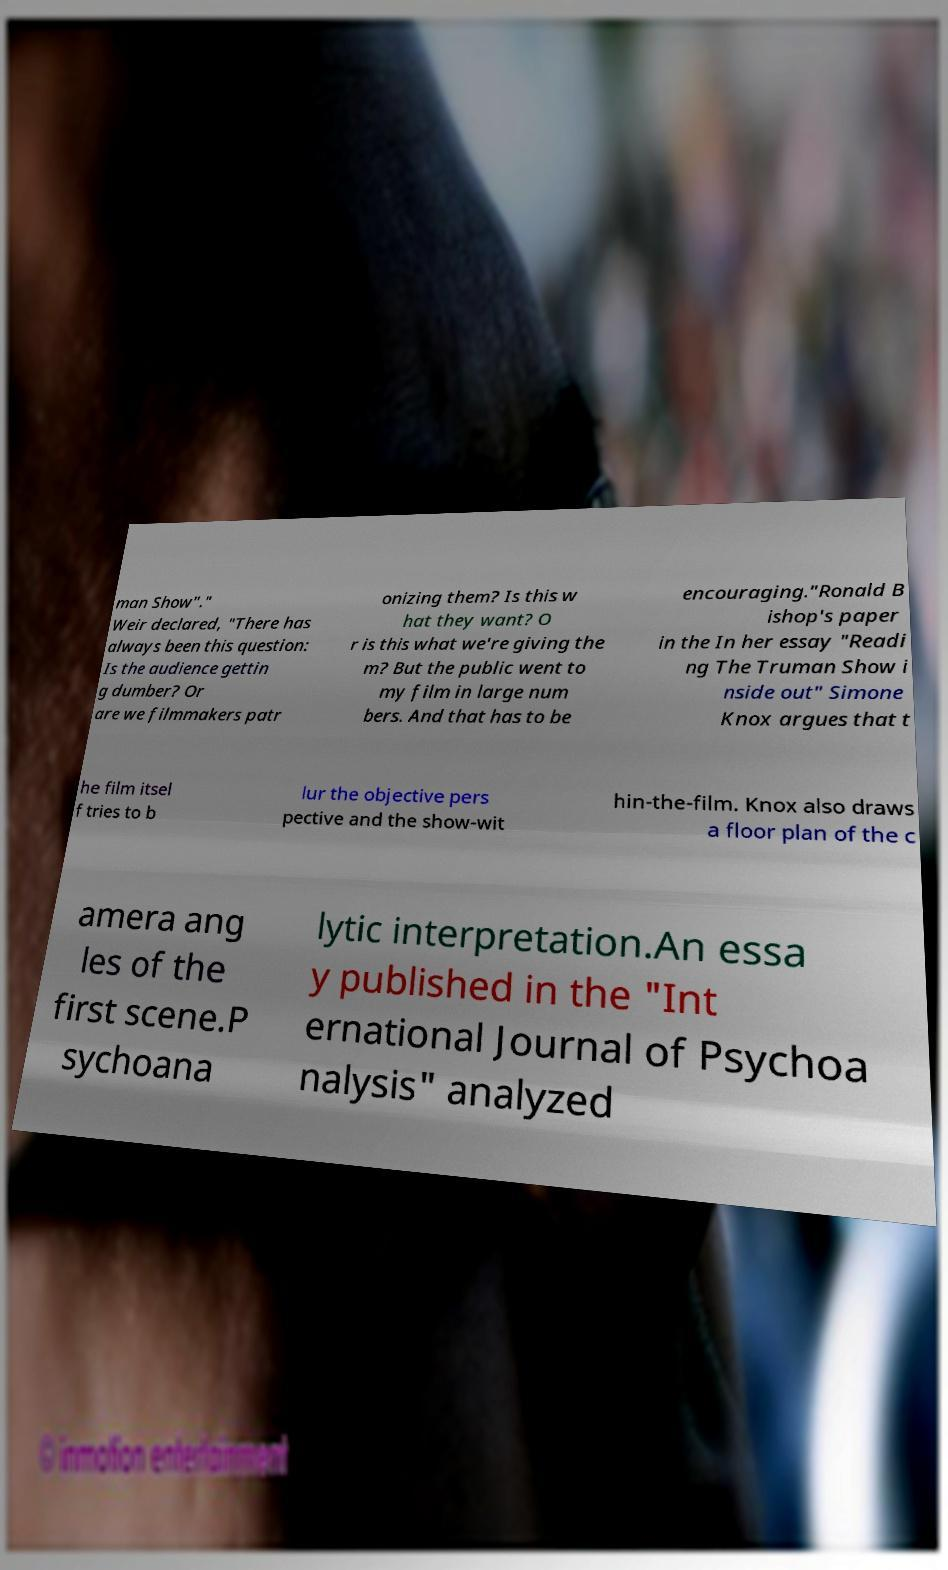Can you read and provide the text displayed in the image?This photo seems to have some interesting text. Can you extract and type it out for me? man Show"." Weir declared, "There has always been this question: Is the audience gettin g dumber? Or are we filmmakers patr onizing them? Is this w hat they want? O r is this what we're giving the m? But the public went to my film in large num bers. And that has to be encouraging."Ronald B ishop's paper in the In her essay "Readi ng The Truman Show i nside out" Simone Knox argues that t he film itsel f tries to b lur the objective pers pective and the show-wit hin-the-film. Knox also draws a floor plan of the c amera ang les of the first scene.P sychoana lytic interpretation.An essa y published in the "Int ernational Journal of Psychoa nalysis" analyzed 